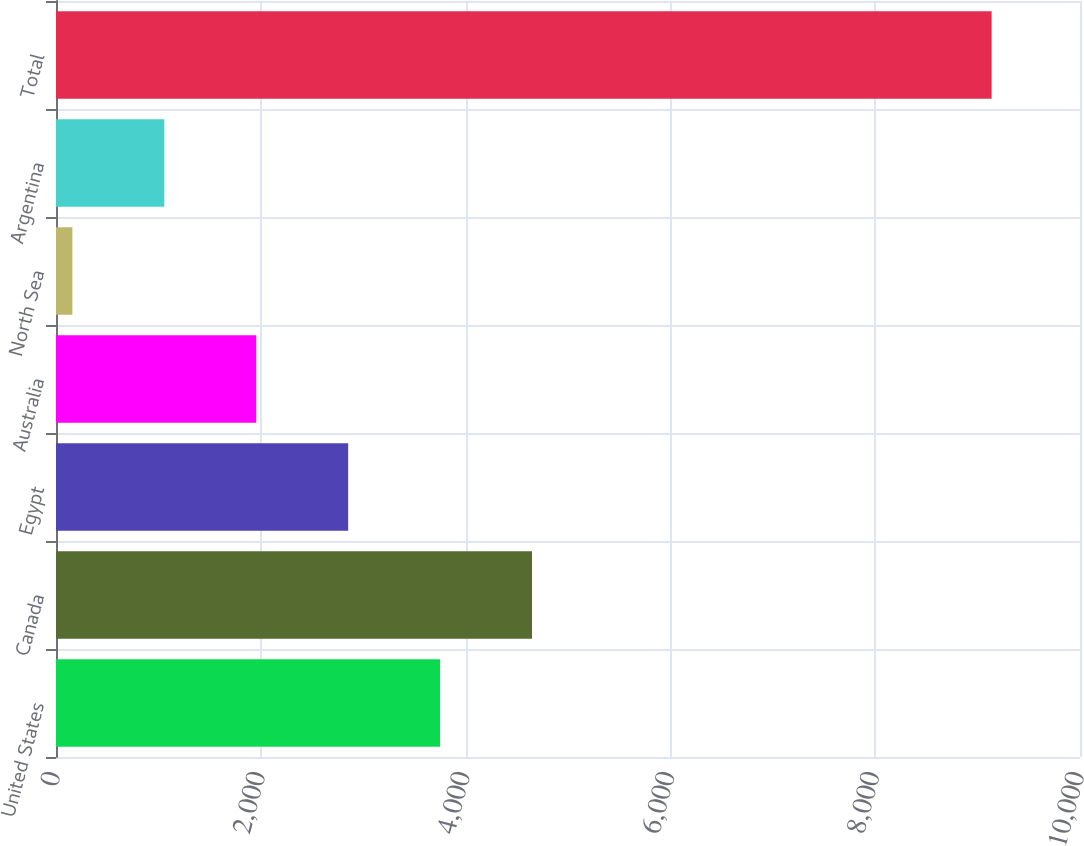Convert chart to OTSL. <chart><loc_0><loc_0><loc_500><loc_500><bar_chart><fcel>United States<fcel>Canada<fcel>Egypt<fcel>Australia<fcel>North Sea<fcel>Argentina<fcel>Total<nl><fcel>3750.8<fcel>4648.5<fcel>2853.1<fcel>1955.4<fcel>160<fcel>1057.7<fcel>9137<nl></chart> 